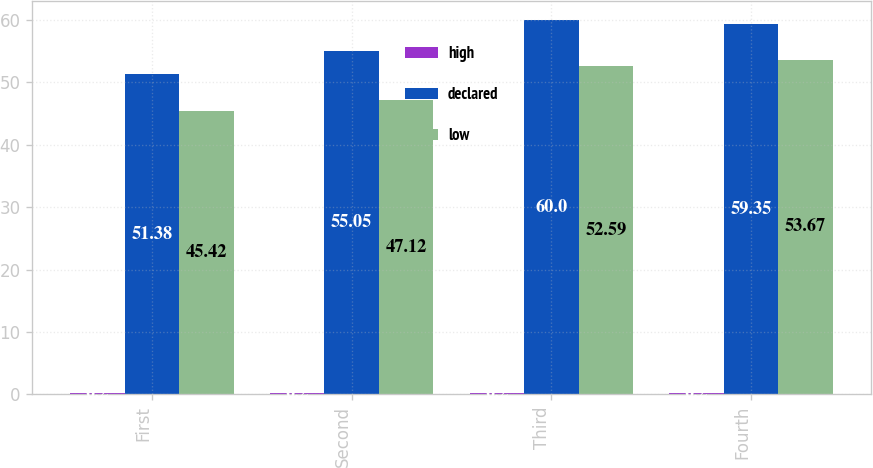<chart> <loc_0><loc_0><loc_500><loc_500><stacked_bar_chart><ecel><fcel>First<fcel>Second<fcel>Third<fcel>Fourth<nl><fcel>high<fcel>0.2<fcel>0.2<fcel>0.2<fcel>0.2<nl><fcel>declared<fcel>51.38<fcel>55.05<fcel>60<fcel>59.35<nl><fcel>low<fcel>45.42<fcel>47.12<fcel>52.59<fcel>53.67<nl></chart> 